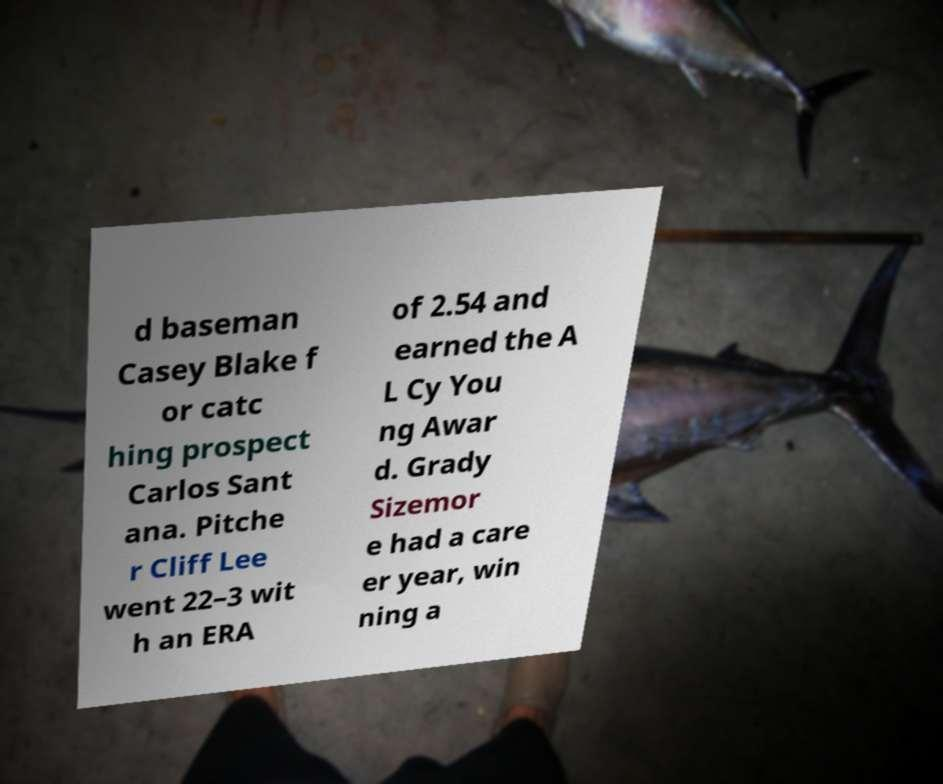Please read and relay the text visible in this image. What does it say? d baseman Casey Blake f or catc hing prospect Carlos Sant ana. Pitche r Cliff Lee went 22–3 wit h an ERA of 2.54 and earned the A L Cy You ng Awar d. Grady Sizemor e had a care er year, win ning a 